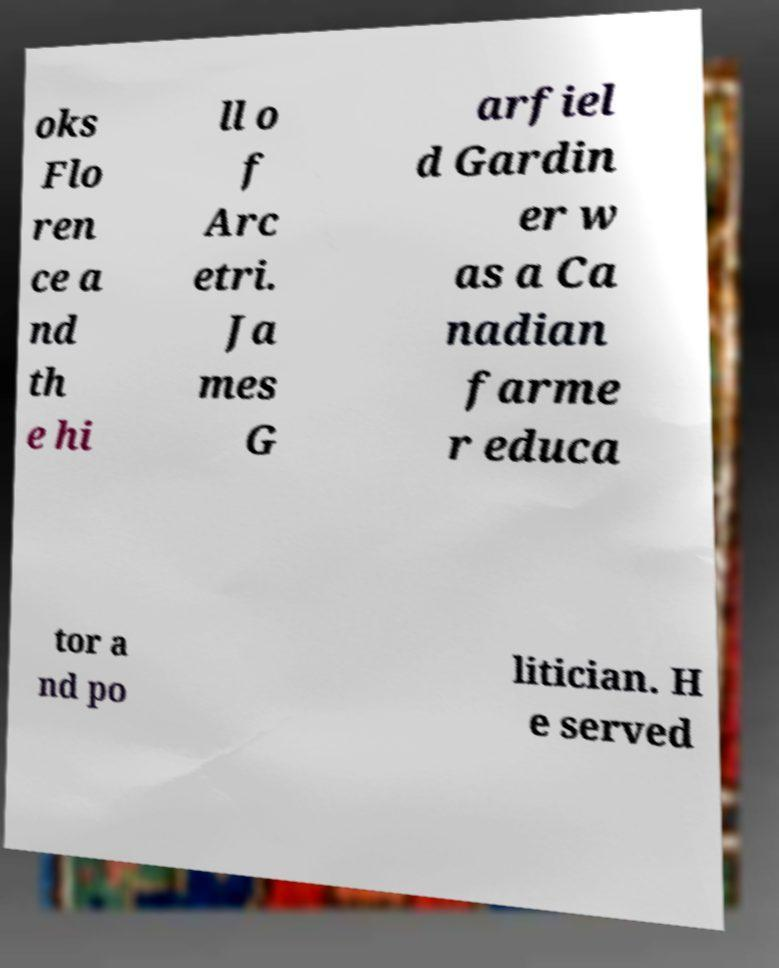There's text embedded in this image that I need extracted. Can you transcribe it verbatim? oks Flo ren ce a nd th e hi ll o f Arc etri. Ja mes G arfiel d Gardin er w as a Ca nadian farme r educa tor a nd po litician. H e served 